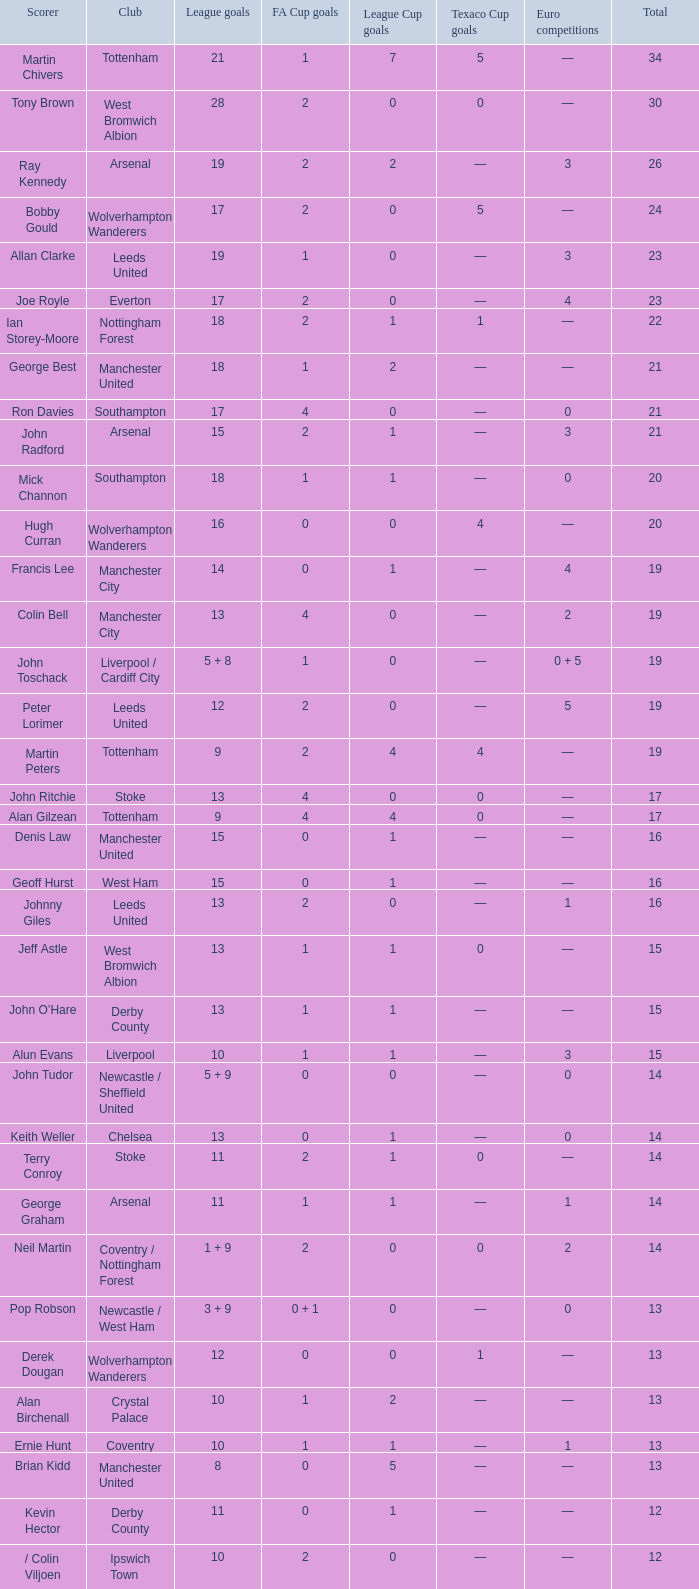What is the aggregate amount of total, when the club is leeds united, and when league goals is 13? 1.0. 